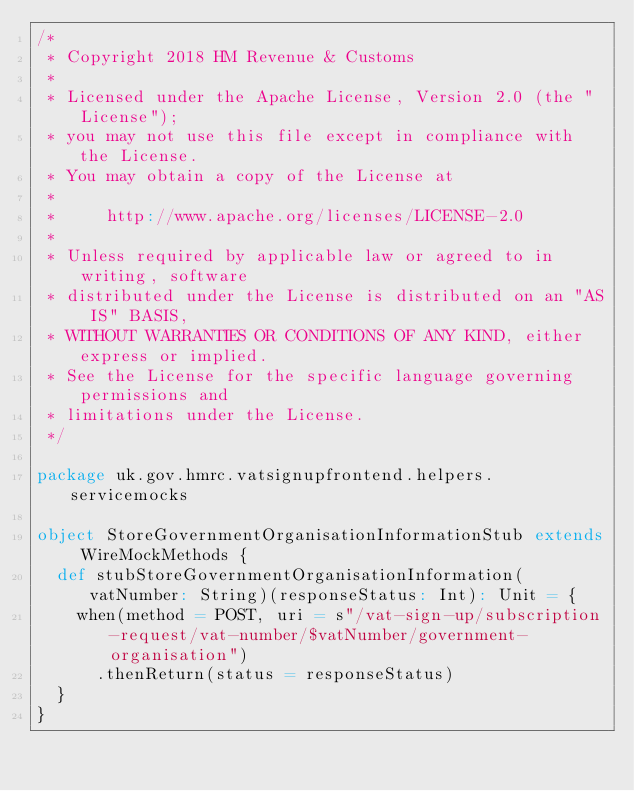<code> <loc_0><loc_0><loc_500><loc_500><_Scala_>/*
 * Copyright 2018 HM Revenue & Customs
 *
 * Licensed under the Apache License, Version 2.0 (the "License");
 * you may not use this file except in compliance with the License.
 * You may obtain a copy of the License at
 *
 *     http://www.apache.org/licenses/LICENSE-2.0
 *
 * Unless required by applicable law or agreed to in writing, software
 * distributed under the License is distributed on an "AS IS" BASIS,
 * WITHOUT WARRANTIES OR CONDITIONS OF ANY KIND, either express or implied.
 * See the License for the specific language governing permissions and
 * limitations under the License.
 */

package uk.gov.hmrc.vatsignupfrontend.helpers.servicemocks

object StoreGovernmentOrganisationInformationStub extends WireMockMethods {
  def stubStoreGovernmentOrganisationInformation(vatNumber: String)(responseStatus: Int): Unit = {
    when(method = POST, uri = s"/vat-sign-up/subscription-request/vat-number/$vatNumber/government-organisation")
      .thenReturn(status = responseStatus)
  }
}
</code> 